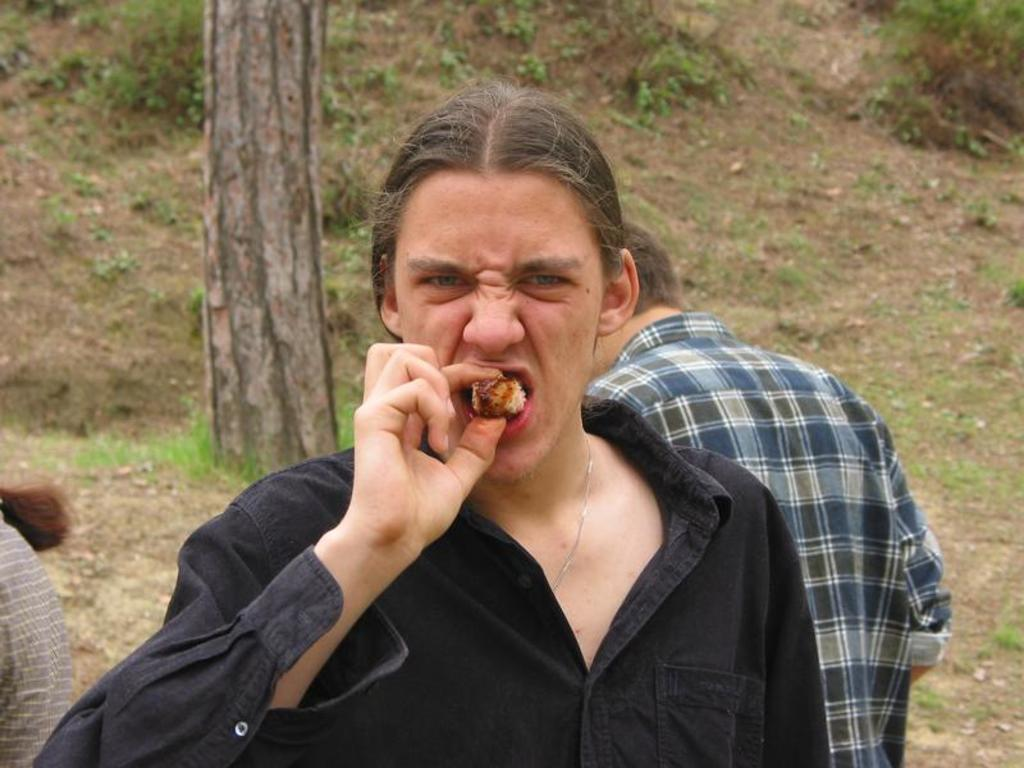What is the person in the image doing? There is a person eating a food item in the image. Can you describe the setting of the image? There is a grassland and a tree in the image. Are there any other people visible in the image? Yes, there are two persons standing in the background of the image. What type of education is being provided in the image? There is no indication of education being provided in the image. What is the cracker doing in the image? There is no cracker present in the image. 